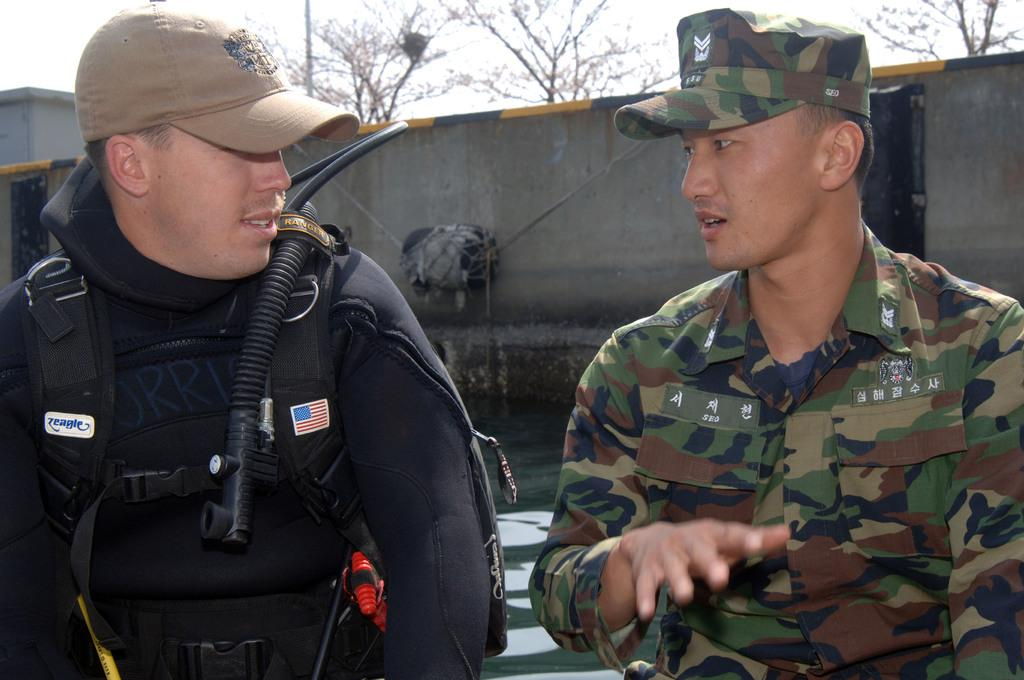How many people are in the image? There are two people in the image. What are the people wearing on their heads? Both people are wearing caps. What can be seen on the wall in the image? There are objects visible on the wall in the image. What is visible in the background of the image? There are trees in the background of the image. What theory does the stranger in the image propose about the trees in the background? There is no stranger present in the image, and therefore no theory can be proposed about the trees in the background. 